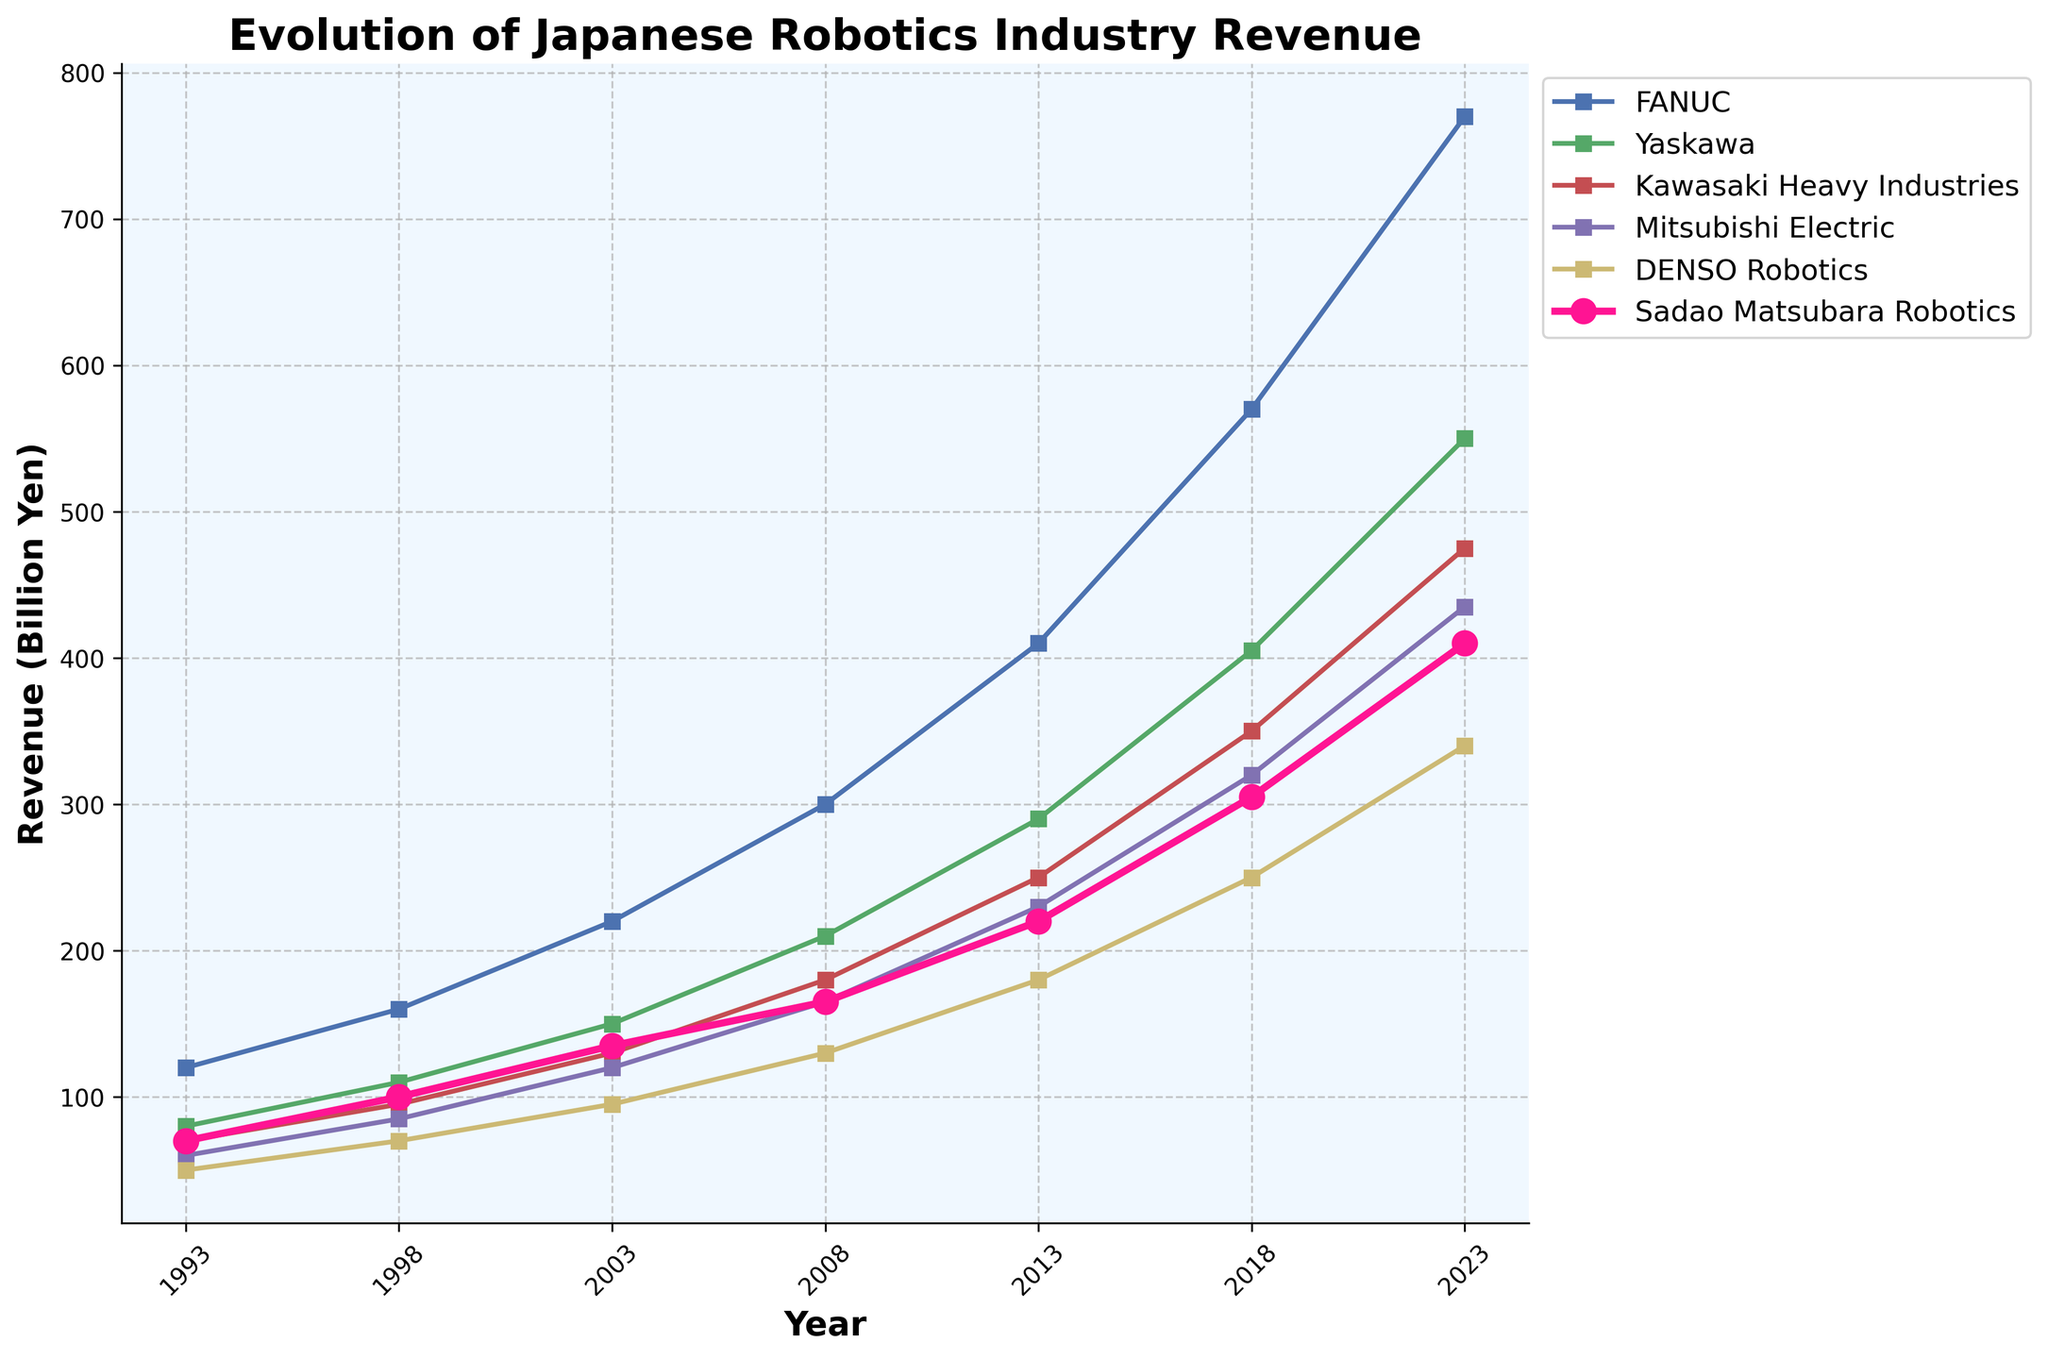What's the total revenue of the Japanese robotics industry in 2018? Look for the data point on the "Total Revenue" line for the year 2018. It indicates the total revenue of the industry for that year.
Answer: 2200 Billion Yen Between FANUC and Sadao Matsubara Robotics, which company had higher revenue in 2023 and by how much? Compare the data points for FANUC and Sadao Matsubara Robotics in 2023. FANUC had a revenue of 770 billion yen, and Sadao Matsubara Robotics had 410 billion yen. Subtract the latter from the former to find the difference.
Answer: FANUC by 360 Billion Yen Which company experienced the largest revenue increase between 1998 and 2003? Calculate the revenue increase for each company by subtracting their 1998 revenue from their 2003 revenue. Identify the company with the highest result: 
FANUC: 220 - 160 = 60 
Yaskawa: 150 - 110 = 40 
Kawasaki Heavy Industries: 130 - 95 = 35 
Mitsubishi Electric: 120 - 85 = 35 
DENSO Robotics: 95 - 70 = 25 
Sadao Matsubara Robotics: 135 - 100 = 35 
FANUC has the largest increase with 60
Answer: FANUC How much larger was the total revenue in 2023 compared to the total revenue in 1993? Subtract the total revenue of 1993 from the total revenue of 2023: 
2980 - 450 = 2530
Answer: 2530 Billion Yen What's the average revenue of Yaskawa over the years presented? Calculate the average by summing up Yaskawa's revenues for all the years and then divide by the number of years:
(80 + 110 + 150 + 210 + 290 + 405 + 550) / 7 = 1795 / 7 = 256.43
Answer: 256.43 Billion Yen Which two companies had the closest revenue values in 2013? Compare the revenues of all companies in 2013 and find the smallest difference between any two companies' revenues:
FANUC: 410, Yaskawa: 290, Kawasaki Heavy Industries: 250, Mitsubishi Electric: 230, DENSO Robotics: 180, Sadao Matsubara Robotics: 220.
Difference: 
FANUC - Yaskawa = 120 
FANUC - Kawasaki Heavy Industries = 160 
FANUC - Mitsubishi Electric = 180 
FANUC - DENSO Robotics = 230 
FANUC - Sadao Matsubara Robotics = 190 
Yaskawa - Kawasaki Heavy Industries = 40
Yaskawa - Mitsubishi Electric = 60
Yaskawa - DENSO Robotics = 110
Yaskawa - Sadao Matsubara Robotics = 70
Kawasaki Heavy Industries - Mitsubishi Electric = 20
Kawasaki Heavy Industries - DENSO Robotics = 70
Kawasaki Heavy Industries - Sadao Matsubara Robotics = 30
Mitsubishi Electric - DENSO Robotics = 50
Mitsubishi Electric - Sadao Matsubara Robotics = 10
DENSO Robotics - Sadao Matsubara Robotics = 40
The closest values were Mitsubishi Electric and Sadao Matsubara Robotics with a difference of 10
Answer: Mitsubishi Electric and Sadao Matsubara Robotics Which company's revenue grew the most from 2008 to 2023? Calculate the growth for each company by subtracting their 2008 revenue from their 2023 revenue. Identify the company with the highest growth:
FANUC: 770 - 300 = 470 
Yaskawa: 550 - 210 = 340 
Kawasaki Heavy Industries: 475 - 180 = 295 
Mitsubishi Electric: 435 - 165 = 270 
DENSO Robotics: 340 - 130 = 210 
Sadao Matsubara Robotics: 410 - 165 = 245 
FANUC has the highest growth with 470
Answer: FANUC 